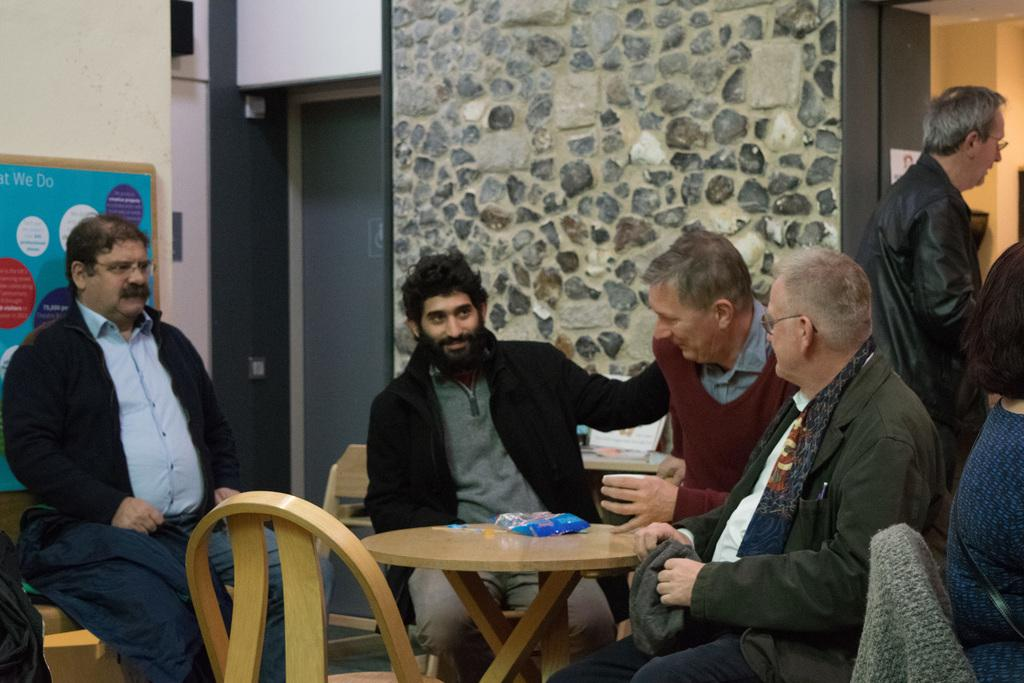How many people are in the image? There is a group of people in the image, but the exact number is not specified. What are the people doing in the image? The people are sitting in chairs in the image. What can be seen in the background of the image? There is a wall and a board in the background of the image. How many geese are visible in the image? There are no geese present in the image. What type of brass instrument is being played by the people in the image? There is no brass instrument or indication of any musical activity in the image. 